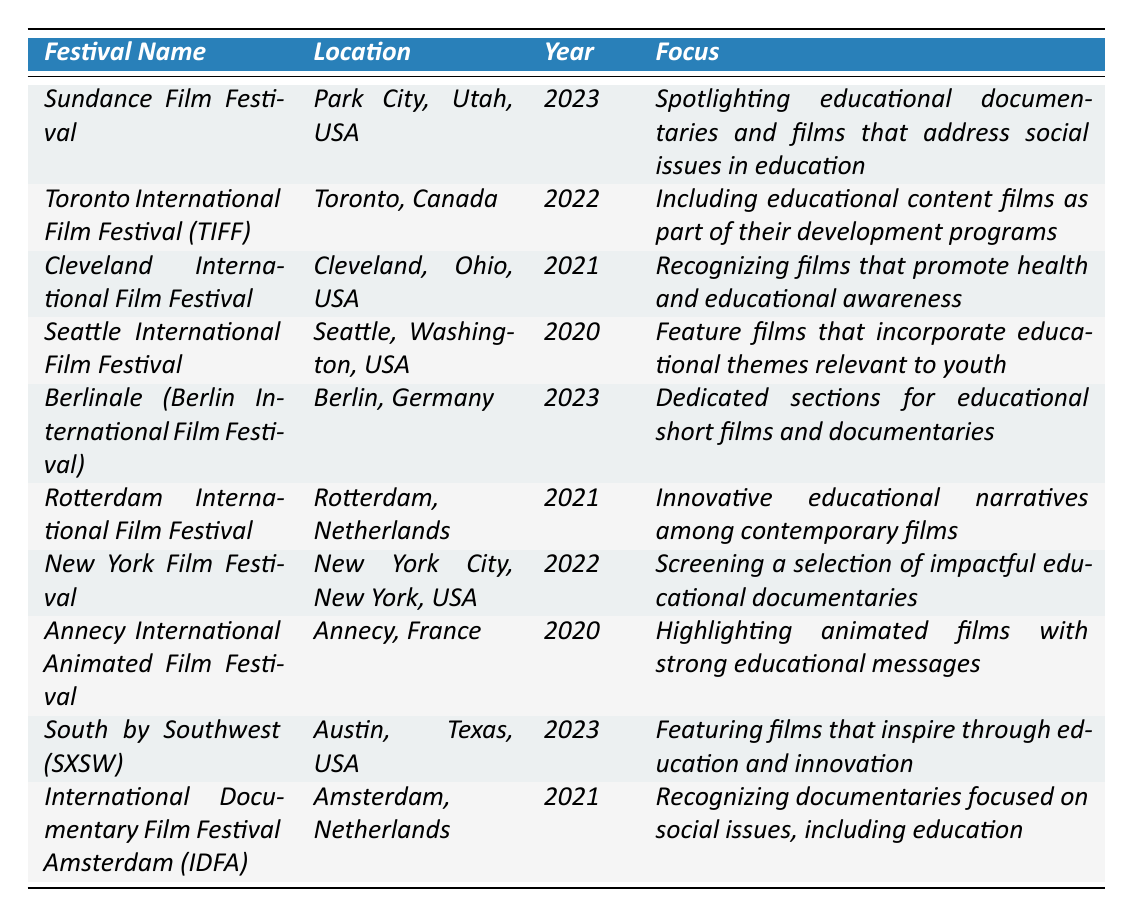What is the location of the Sundance Film Festival? The table lists the location for each festival. For the Sundance Film Festival, it specifies "Park City, Utah, USA."
Answer: Park City, Utah, USA In which year did the Toronto International Film Festival take place? By examining the table, we see that the entry for the Toronto International Film Festival indicates the year as "2022."
Answer: 2022 How many festivals were held in 2023? The table has two entries with the year "2023" (Sundance Film Festival and South by Southwest). Therefore, by counting these entries, we find that two festivals took place in this year.
Answer: 2 What is the focus of the Cleveland International Film Festival? The table shows that the focus of the Cleveland International Film Festival is to recognize "films that promote health and educational awareness."
Answer: Films that promote health and educational awareness Which film festival in 2023 is dedicated to educational short films? Looking at the 2023 entries, the "Berlinale (Berlin International Film Festival)" has a focus on "dedicated sections for educational short films and documentaries."
Answer: Berlinale (Berlin International Film Festival) Is the Seattle International Film Festival focused on educational themes? The table indicates that the Seattle International Film Festival features films that incorporate "educational themes relevant to youth," so the answer is yes.
Answer: Yes What is the average year of the festivals listed in the table? The years in the table are 2023, 2022, 2021, 2020, 2023, 2021, 2022, 2020, 2023, and 2021. By adding them, we get a total of 20, and since there are 10 festivals, we divide 20 by 10, yielding an average of 2021.
Answer: 2021 How many festivals took place in Europe? By checking the locations, the festivals held in Europe are Berlinale, Rotterdam, Annecy, and IDFA. Thus, there are four festivals in total that took place in Europe.
Answer: 4 Did the South by Southwest festival feature films that inspire through education? The focus for the South by Southwest festival in the table highlights "films that inspire through education and innovation," so the answer is true.
Answer: True Which festival has a focus on animated films with educational messages? The entry for the Annecy International Animated Film Festival explicitly states its focus is on "highlighting animated films with strong educational messages."
Answer: Annecy International Animated Film Festival What distinguishes the festival focus of the Rotterdam International Film Festival from others? Rotterdam International Film Festival highlights "innovative educational narratives among contemporary films," which sets it apart since it emphasizes narratives in innovation.
Answer: Innovative educational narratives among contemporary films 